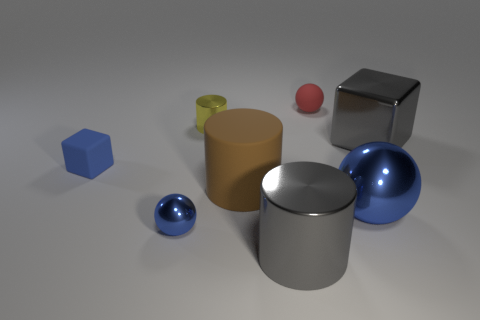The yellow object that is the same size as the red sphere is what shape? The yellow object, displaying characteristics typical of a geometric cylinder, shares a similar size attribute with the red sphere. The shape of the cylinder is defined by its circular top and bottom faces connected by a curved surface, distinct from the red sphere's completely rounded form. 